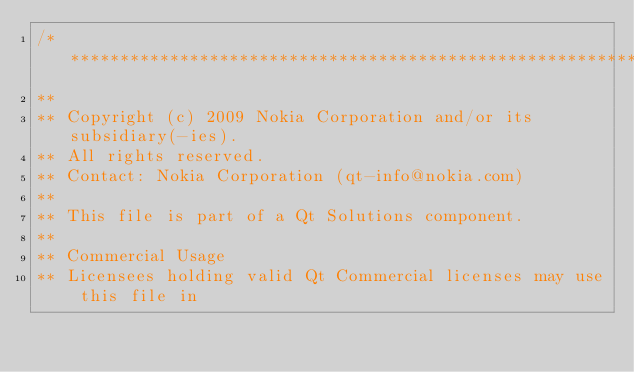Convert code to text. <code><loc_0><loc_0><loc_500><loc_500><_C_>/****************************************************************************
**
** Copyright (c) 2009 Nokia Corporation and/or its subsidiary(-ies).
** All rights reserved.
** Contact: Nokia Corporation (qt-info@nokia.com)
**
** This file is part of a Qt Solutions component.
**
** Commercial Usage
** Licensees holding valid Qt Commercial licenses may use this file in</code> 